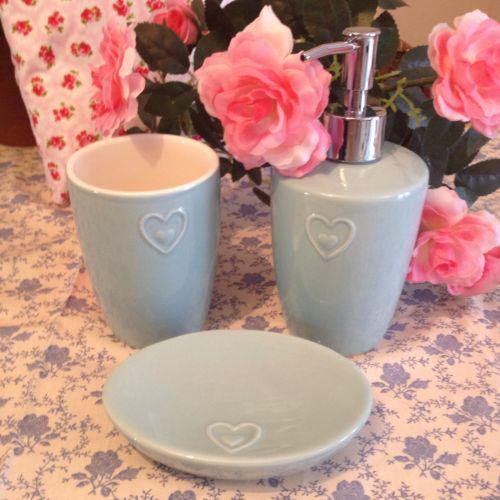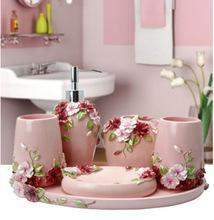The first image is the image on the left, the second image is the image on the right. For the images shown, is this caption "The image on the right has pink flowers inside of a vase." true? Answer yes or no. No. 